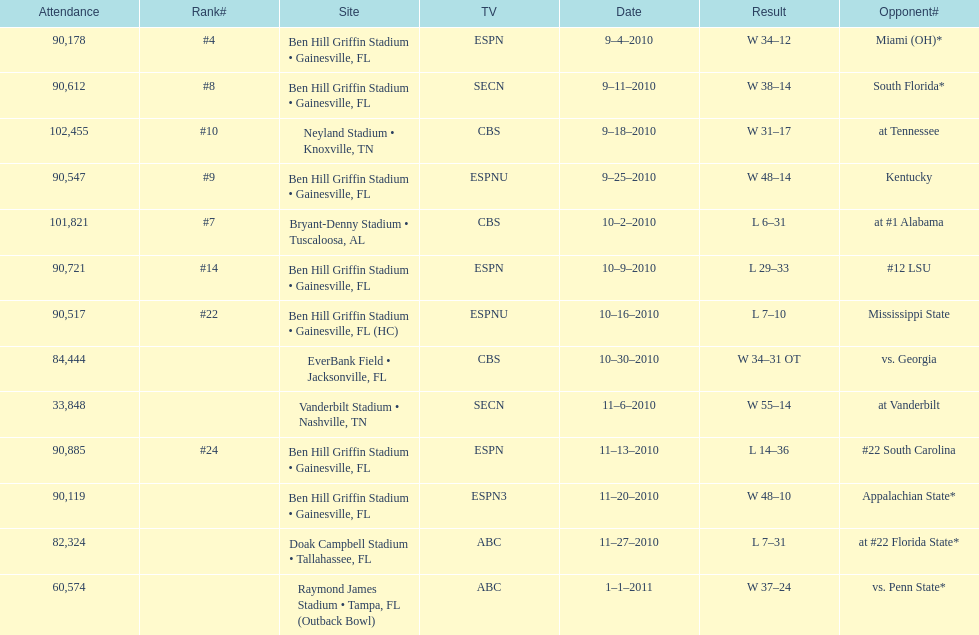The gators won the game on september 25, 2010. who won the previous game? Gators. Can you give me this table as a dict? {'header': ['Attendance', 'Rank#', 'Site', 'TV', 'Date', 'Result', 'Opponent#'], 'rows': [['90,178', '#4', 'Ben Hill Griffin Stadium • Gainesville, FL', 'ESPN', '9–4–2010', 'W\xa034–12', 'Miami (OH)*'], ['90,612', '#8', 'Ben Hill Griffin Stadium • Gainesville, FL', 'SECN', '9–11–2010', 'W\xa038–14', 'South Florida*'], ['102,455', '#10', 'Neyland Stadium • Knoxville, TN', 'CBS', '9–18–2010', 'W\xa031–17', 'at\xa0Tennessee'], ['90,547', '#9', 'Ben Hill Griffin Stadium • Gainesville, FL', 'ESPNU', '9–25–2010', 'W\xa048–14', 'Kentucky'], ['101,821', '#7', 'Bryant-Denny Stadium • Tuscaloosa, AL', 'CBS', '10–2–2010', 'L\xa06–31', 'at\xa0#1\xa0Alabama'], ['90,721', '#14', 'Ben Hill Griffin Stadium • Gainesville, FL', 'ESPN', '10–9–2010', 'L\xa029–33', '#12\xa0LSU'], ['90,517', '#22', 'Ben Hill Griffin Stadium • Gainesville, FL (HC)', 'ESPNU', '10–16–2010', 'L\xa07–10', 'Mississippi State'], ['84,444', '', 'EverBank Field • Jacksonville, FL', 'CBS', '10–30–2010', 'W\xa034–31\xa0OT', 'vs.\xa0Georgia'], ['33,848', '', 'Vanderbilt Stadium • Nashville, TN', 'SECN', '11–6–2010', 'W\xa055–14', 'at\xa0Vanderbilt'], ['90,885', '#24', 'Ben Hill Griffin Stadium • Gainesville, FL', 'ESPN', '11–13–2010', 'L\xa014–36', '#22\xa0South Carolina'], ['90,119', '', 'Ben Hill Griffin Stadium • Gainesville, FL', 'ESPN3', '11–20–2010', 'W\xa048–10', 'Appalachian State*'], ['82,324', '', 'Doak Campbell Stadium • Tallahassee, FL', 'ABC', '11–27–2010', 'L\xa07–31', 'at\xa0#22\xa0Florida State*'], ['60,574', '', 'Raymond James Stadium • Tampa, FL (Outback Bowl)', 'ABC', '1–1–2011', 'W\xa037–24', 'vs.\xa0Penn State*']]} 